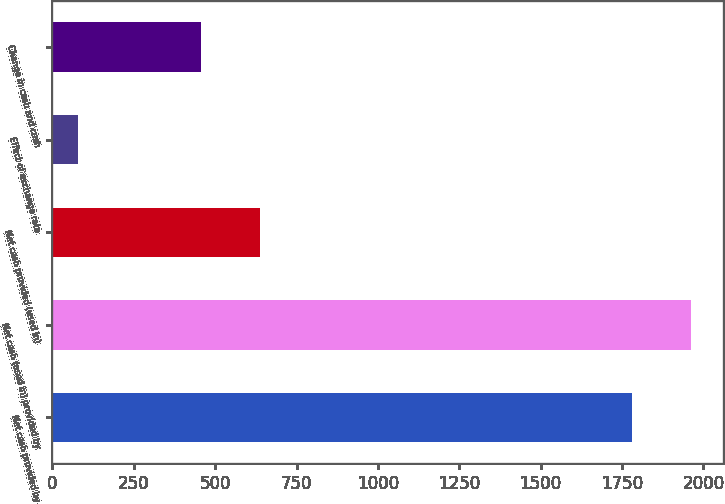<chart> <loc_0><loc_0><loc_500><loc_500><bar_chart><fcel>Net cash provided by<fcel>Net cash (used in) provided by<fcel>Net cash provided (used in)<fcel>Effect of exchange rate<fcel>Change in cash and cash<nl><fcel>1782<fcel>1962.1<fcel>636.1<fcel>77<fcel>456<nl></chart> 